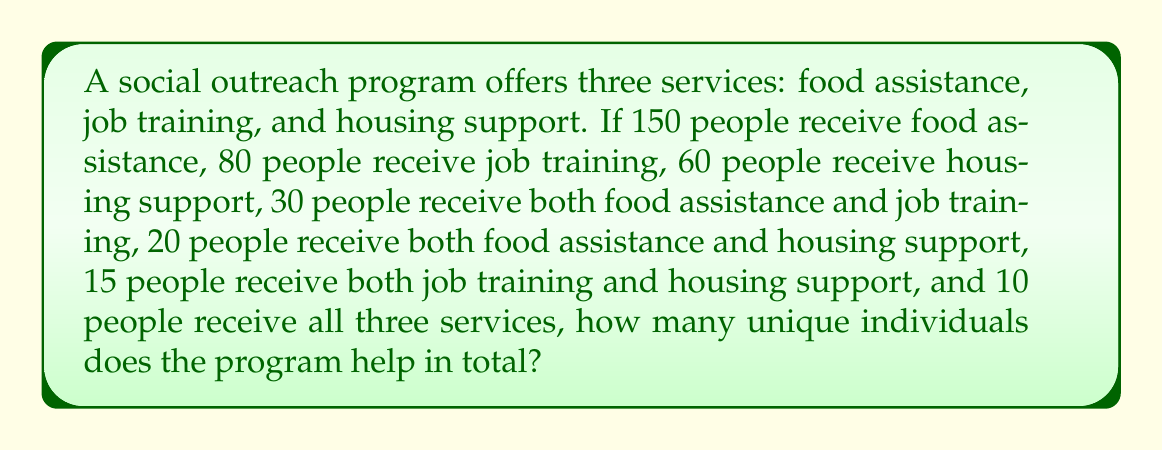Give your solution to this math problem. To solve this problem, we'll use the principle of inclusion-exclusion for three sets. Let's define our sets:

$A$: People receiving food assistance
$B$: People receiving job training
$C$: People receiving housing support

We're given:
$|A| = 150$, $|B| = 80$, $|C| = 60$
$|A \cap B| = 30$, $|A \cap C| = 20$, $|B \cap C| = 15$
$|A \cap B \cap C| = 10$

The formula for the union of three sets is:

$$|A \cup B \cup C| = |A| + |B| + |C| - |A \cap B| - |A \cap C| - |B \cap C| + |A \cap B \cap C|$$

Let's substitute our values:

$$|A \cup B \cup C| = 150 + 80 + 60 - 30 - 20 - 15 + 10$$

Now, let's calculate:

$$|A \cup B \cup C| = 290 - 65 + 10 = 235$$

Therefore, the program helps 235 unique individuals in total.
Answer: 235 individuals 